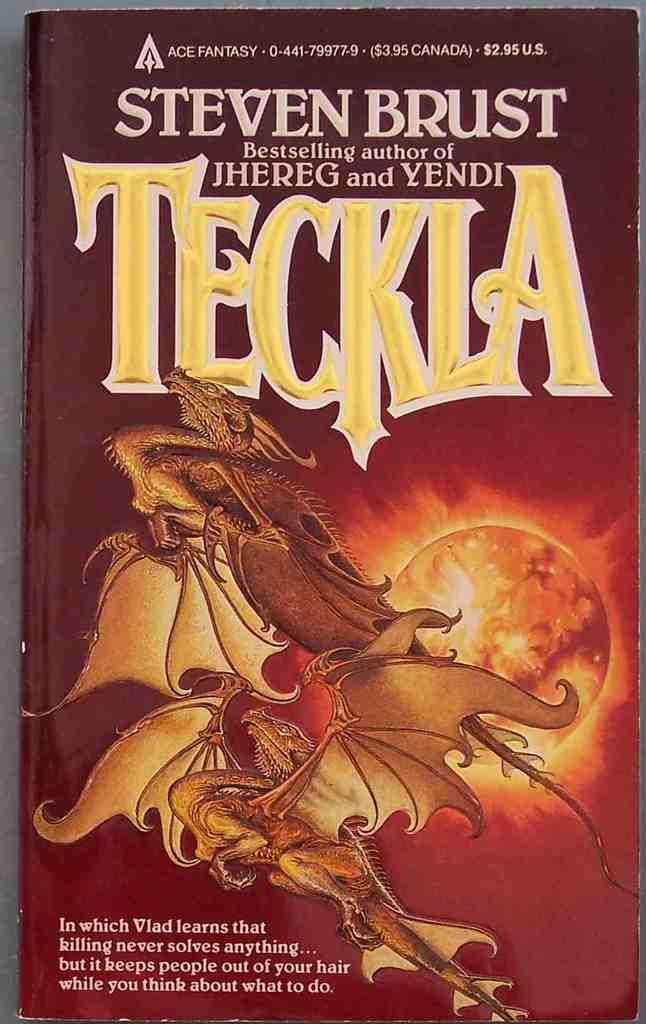What is the name of this book?
Keep it short and to the point. Teckla. Who is the author of the book?
Your answer should be compact. Steven brust. 